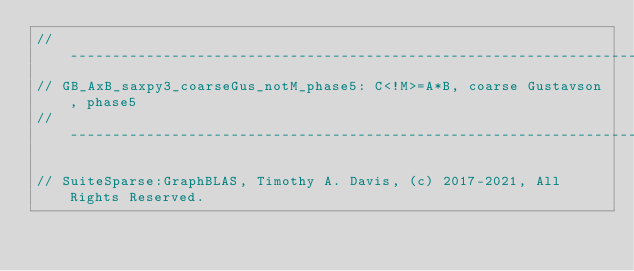<code> <loc_0><loc_0><loc_500><loc_500><_C_>//------------------------------------------------------------------------------
// GB_AxB_saxpy3_coarseGus_notM_phase5: C<!M>=A*B, coarse Gustavson, phase5
//------------------------------------------------------------------------------

// SuiteSparse:GraphBLAS, Timothy A. Davis, (c) 2017-2021, All Rights Reserved.</code> 